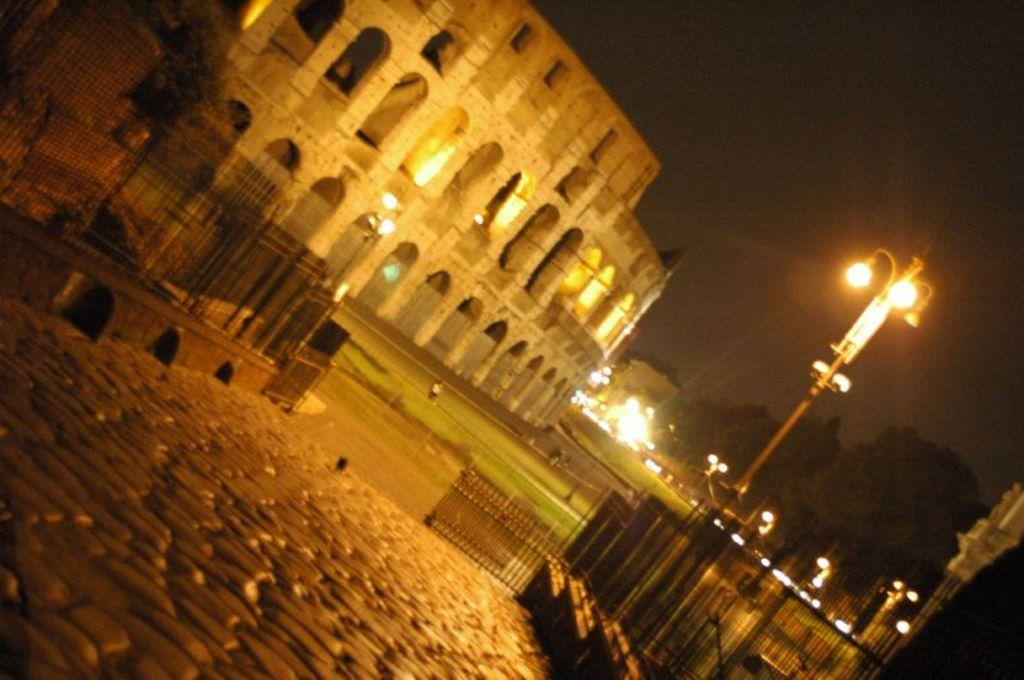At what time of day was the image taken? The image was taken during night time. What type of structure can be seen in the image? There is a building in the image. What other natural elements are present in the image? There are trees in the image. What artificial light sources are visible in the image? Light poles are visible in the image. What type of barrier is present in the image? There is a fence in the image. What type of path is present in the image? A path is present in the image. What type of transportation infrastructure is present in the image? There is a road in the image. What part of the natural environment is visible in the image? The sky is visible in the image. How many wrens can be seen perched on the fence in the image? There are no wrens present in the image; only the fence is visible. What type of tub is visible in the image? There is no tub present in the image. 